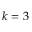<formula> <loc_0><loc_0><loc_500><loc_500>k = 3</formula> 